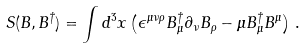Convert formula to latex. <formula><loc_0><loc_0><loc_500><loc_500>S ( B , B ^ { \dagger } ) = \int d ^ { 3 } x \left ( \epsilon ^ { \mu \nu \rho } B _ { \mu } ^ { \dagger } \partial _ { \nu } B _ { \rho } - \mu B _ { \mu } ^ { \dagger } B ^ { \mu } \right ) \, .</formula> 